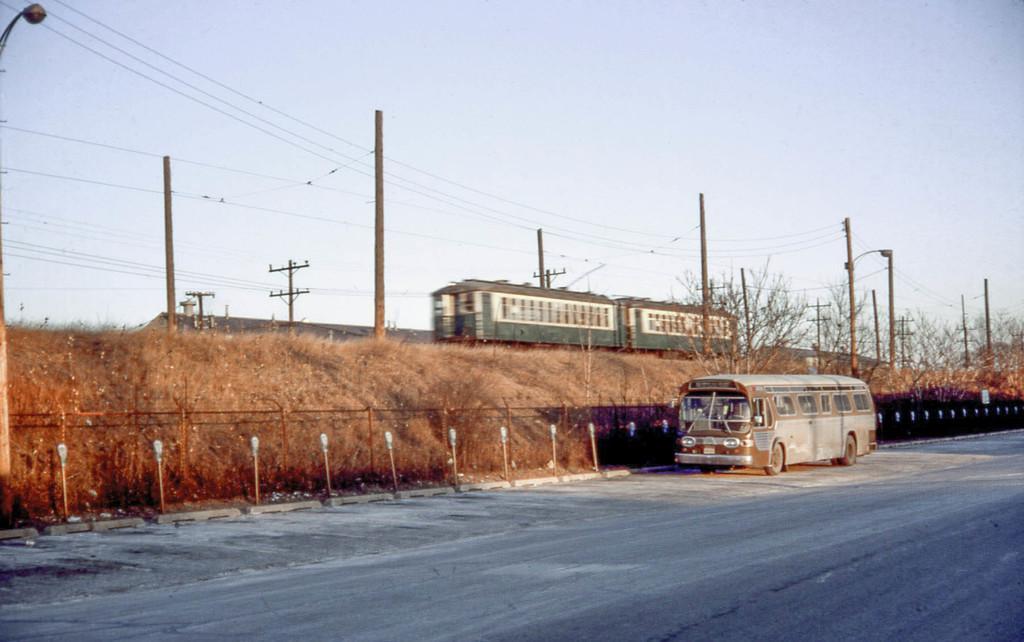In one or two sentences, can you explain what this image depicts? In this image there is a vehicle on the road. There are street lights. There is a metal fence. In the center of the image there is a train. There are poles. There are current polls. In the background of the image there are trees and sky. 